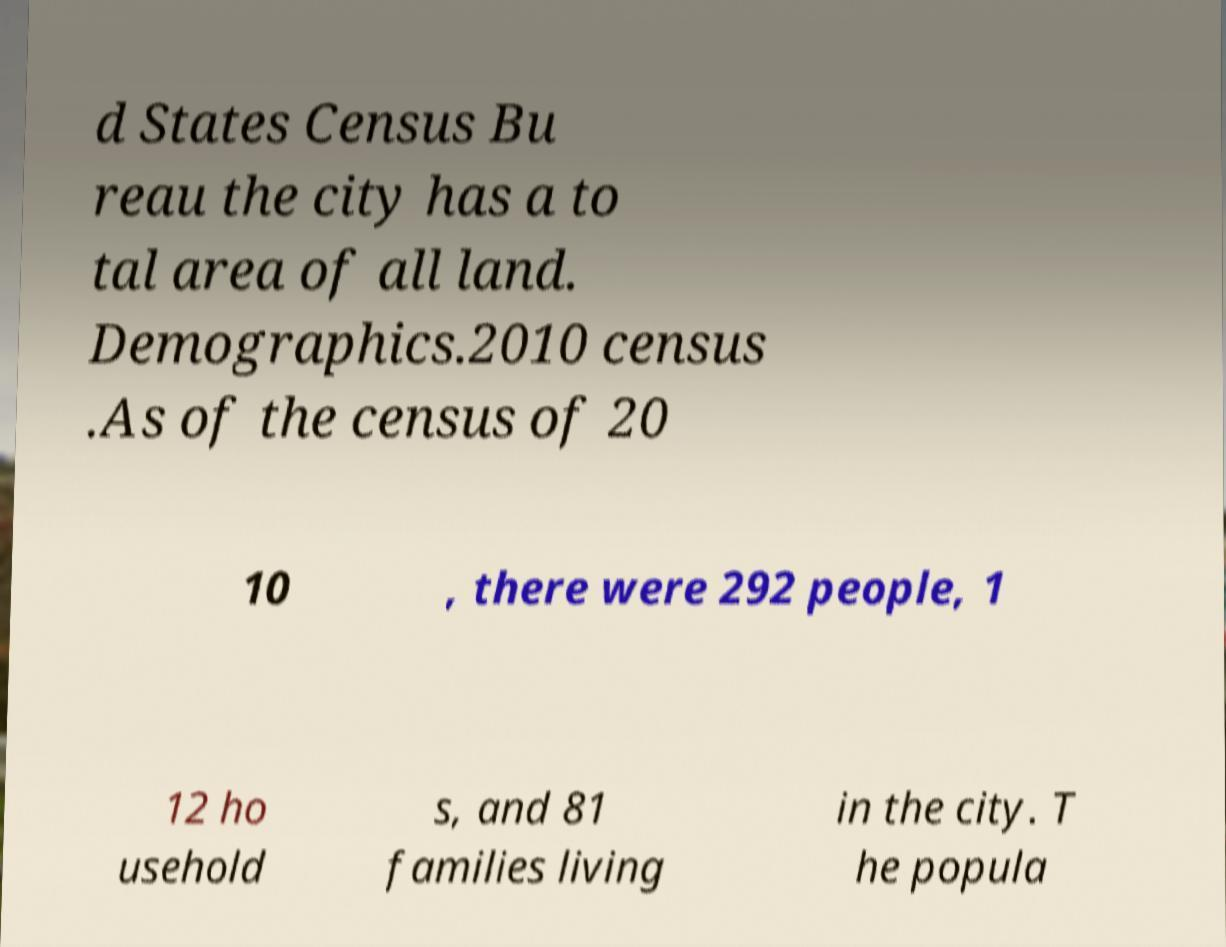Can you accurately transcribe the text from the provided image for me? d States Census Bu reau the city has a to tal area of all land. Demographics.2010 census .As of the census of 20 10 , there were 292 people, 1 12 ho usehold s, and 81 families living in the city. T he popula 